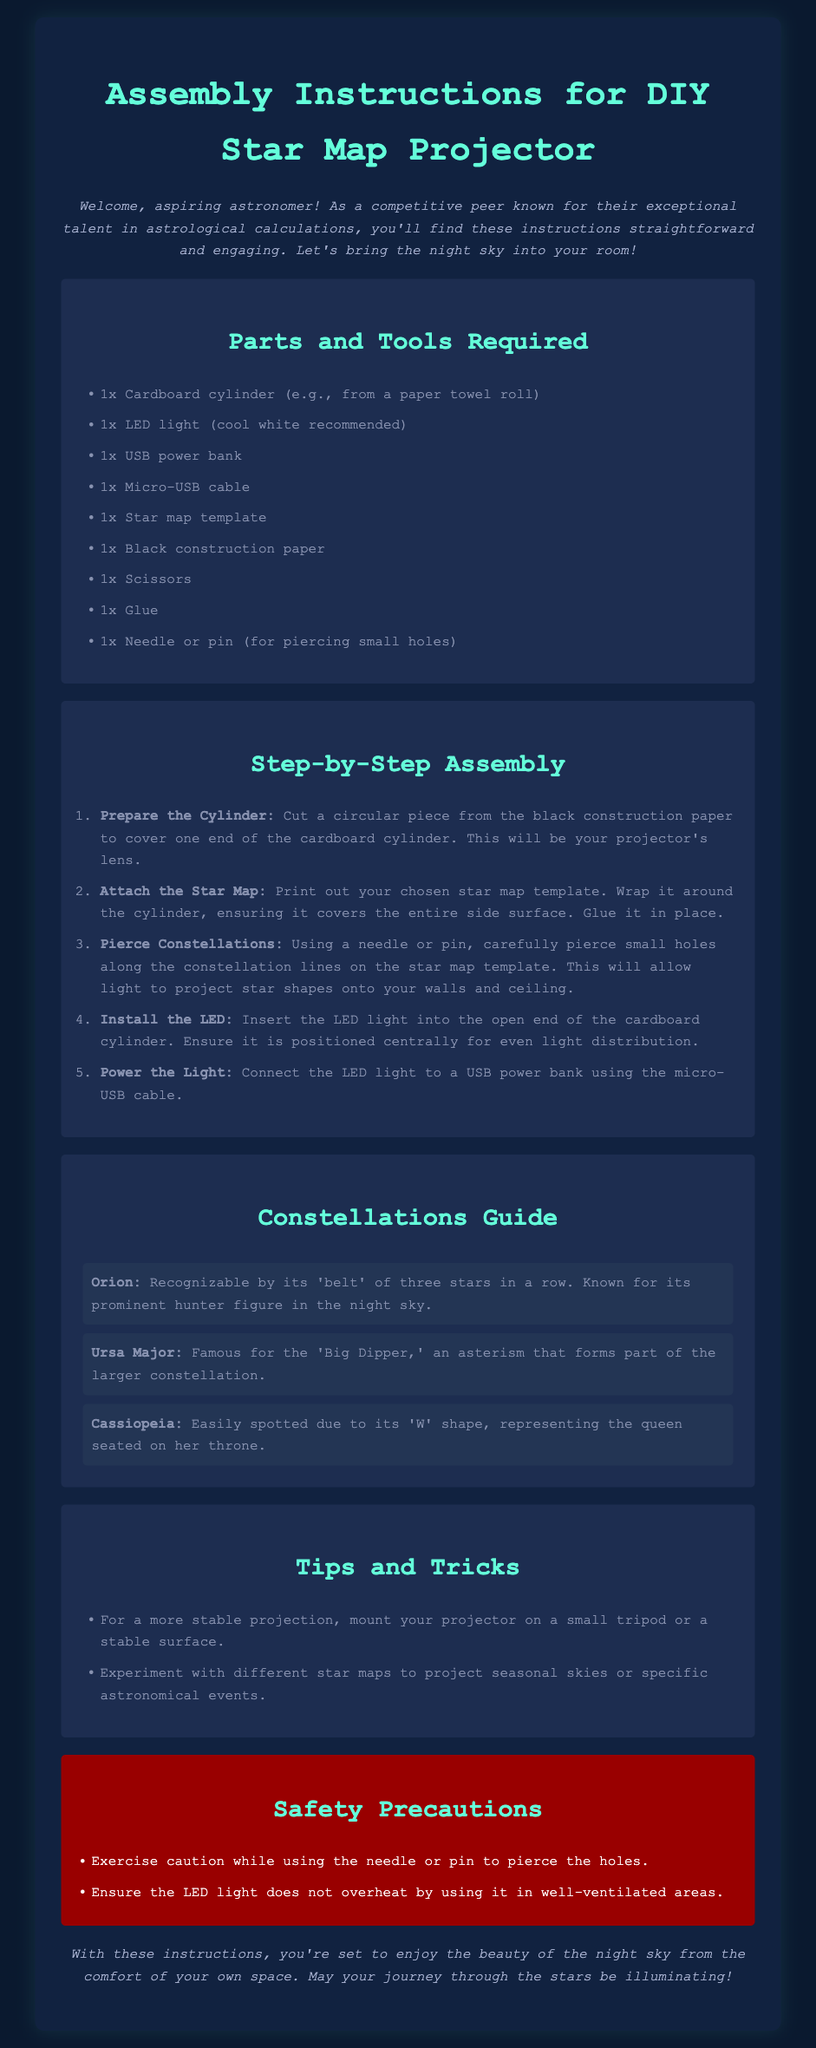What is the primary color scheme of the document? The document primarily features colors like navy blue and light teal, creating a starry night effect.
Answer: navy blue and light teal How many parts are required for assembly? The list of required parts includes a total of nine items for the project.
Answer: 9 What tool is suggested for piercing holes in the star map? A needle or pin is recommended for carefully piercing small holes along the constellation lines.
Answer: needle or pin Which constellation is known for its 'W' shape? Cassiopeia is easily recognized due to its distinctive 'W' shape.
Answer: Cassiopeia What should you use to prevent the LED light from overheating? It is important to ensure the LED light is used in well-ventilated areas to prevent overheating.
Answer: well-ventilated areas Which constellation features the 'Big Dipper'? Ursa Major is famous for containing the 'Big Dipper' asterism.
Answer: Ursa Major What is the first step in the assembly process? The first step involves cutting a circular piece from the black construction paper to serve as the lens.
Answer: Prepare the Cylinder How can you stabilize the projector during use? Mounting the projector on a small tripod or a stable surface is suggested for a more stable projection.
Answer: small tripod or stable surface 